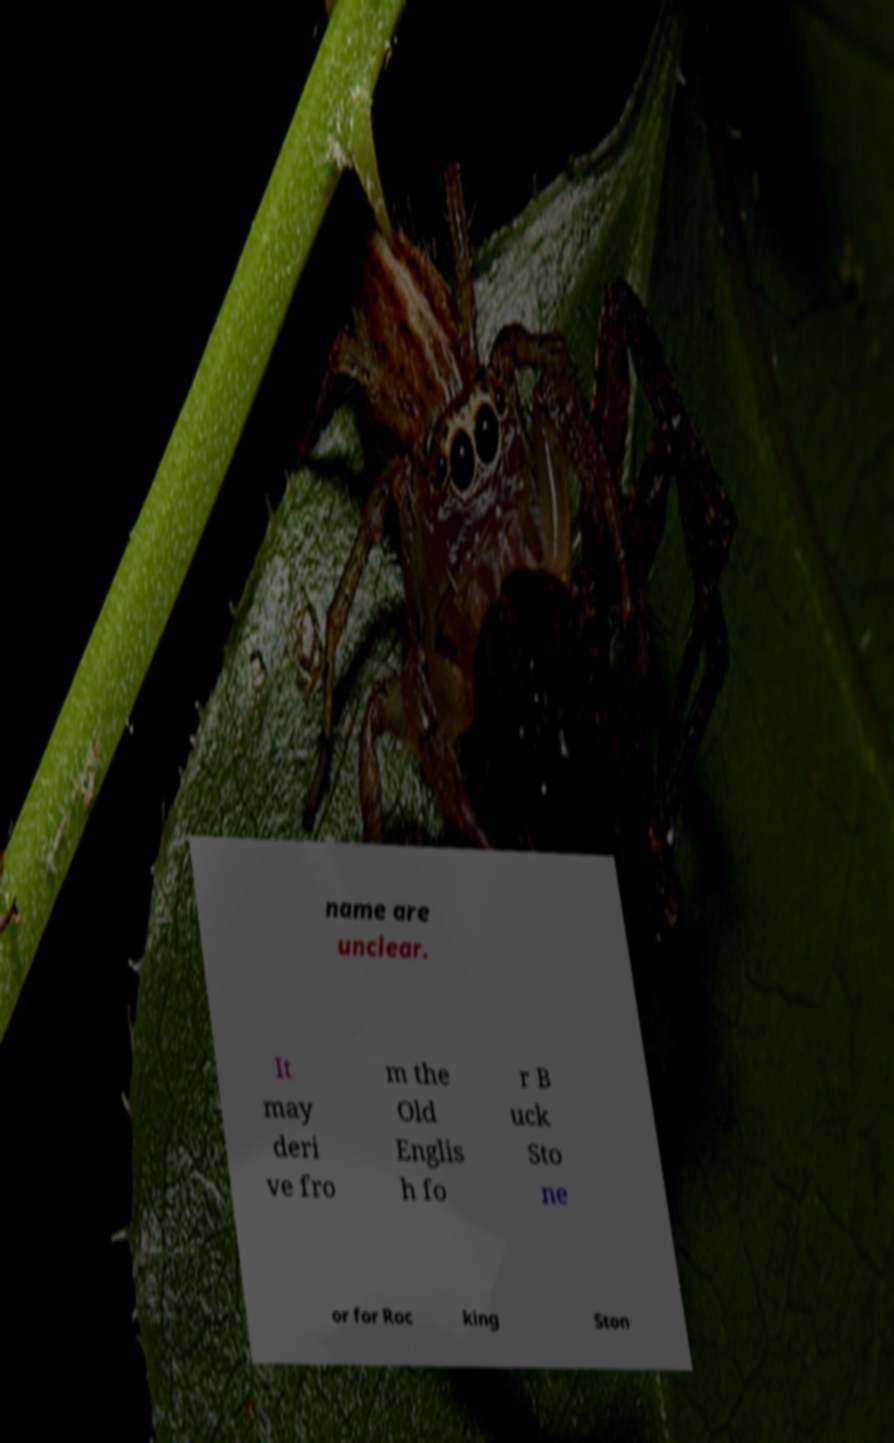Please read and relay the text visible in this image. What does it say? name are unclear. It may deri ve fro m the Old Englis h fo r B uck Sto ne or for Roc king Ston 